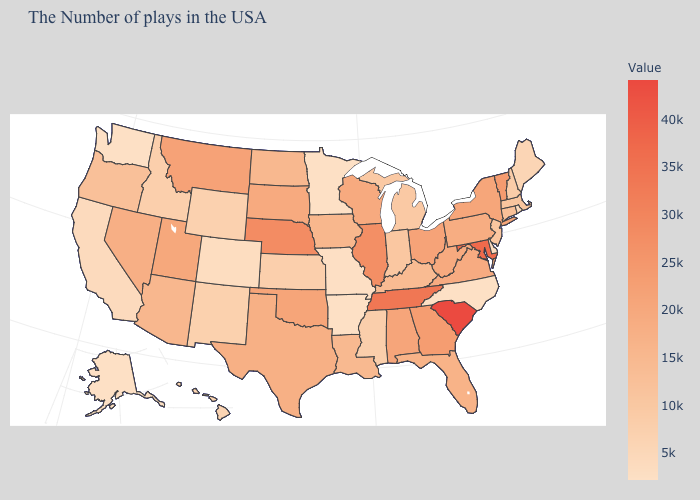Among the states that border Georgia , which have the lowest value?
Quick response, please. North Carolina. Is the legend a continuous bar?
Keep it brief. Yes. Among the states that border Ohio , does Michigan have the highest value?
Answer briefly. No. Which states have the highest value in the USA?
Write a very short answer. South Carolina. Among the states that border Missouri , does Oklahoma have the lowest value?
Short answer required. No. Which states have the lowest value in the USA?
Answer briefly. North Carolina, Arkansas, Minnesota, Washington, Alaska. Does New Hampshire have the lowest value in the USA?
Quick response, please. No. 